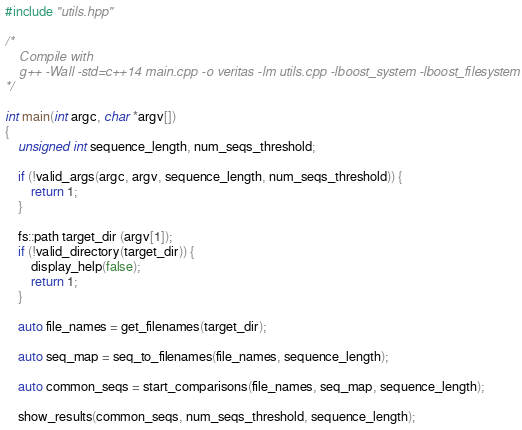<code> <loc_0><loc_0><loc_500><loc_500><_C++_>#include "utils.hpp"

/*
    Compile with
    g++ -Wall -std=c++14 main.cpp -o veritas -lm utils.cpp -lboost_system -lboost_filesystem
*/

int main(int argc, char *argv[])
{
    unsigned int sequence_length, num_seqs_threshold;

    if (!valid_args(argc, argv, sequence_length, num_seqs_threshold)) {
        return 1;
    }

    fs::path target_dir (argv[1]);
    if (!valid_directory(target_dir)) {
        display_help(false);
        return 1;
    }

    auto file_names = get_filenames(target_dir);

    auto seq_map = seq_to_filenames(file_names, sequence_length);

    auto common_seqs = start_comparisons(file_names, seq_map, sequence_length);

    show_results(common_seqs, num_seqs_threshold, sequence_length);
</code> 